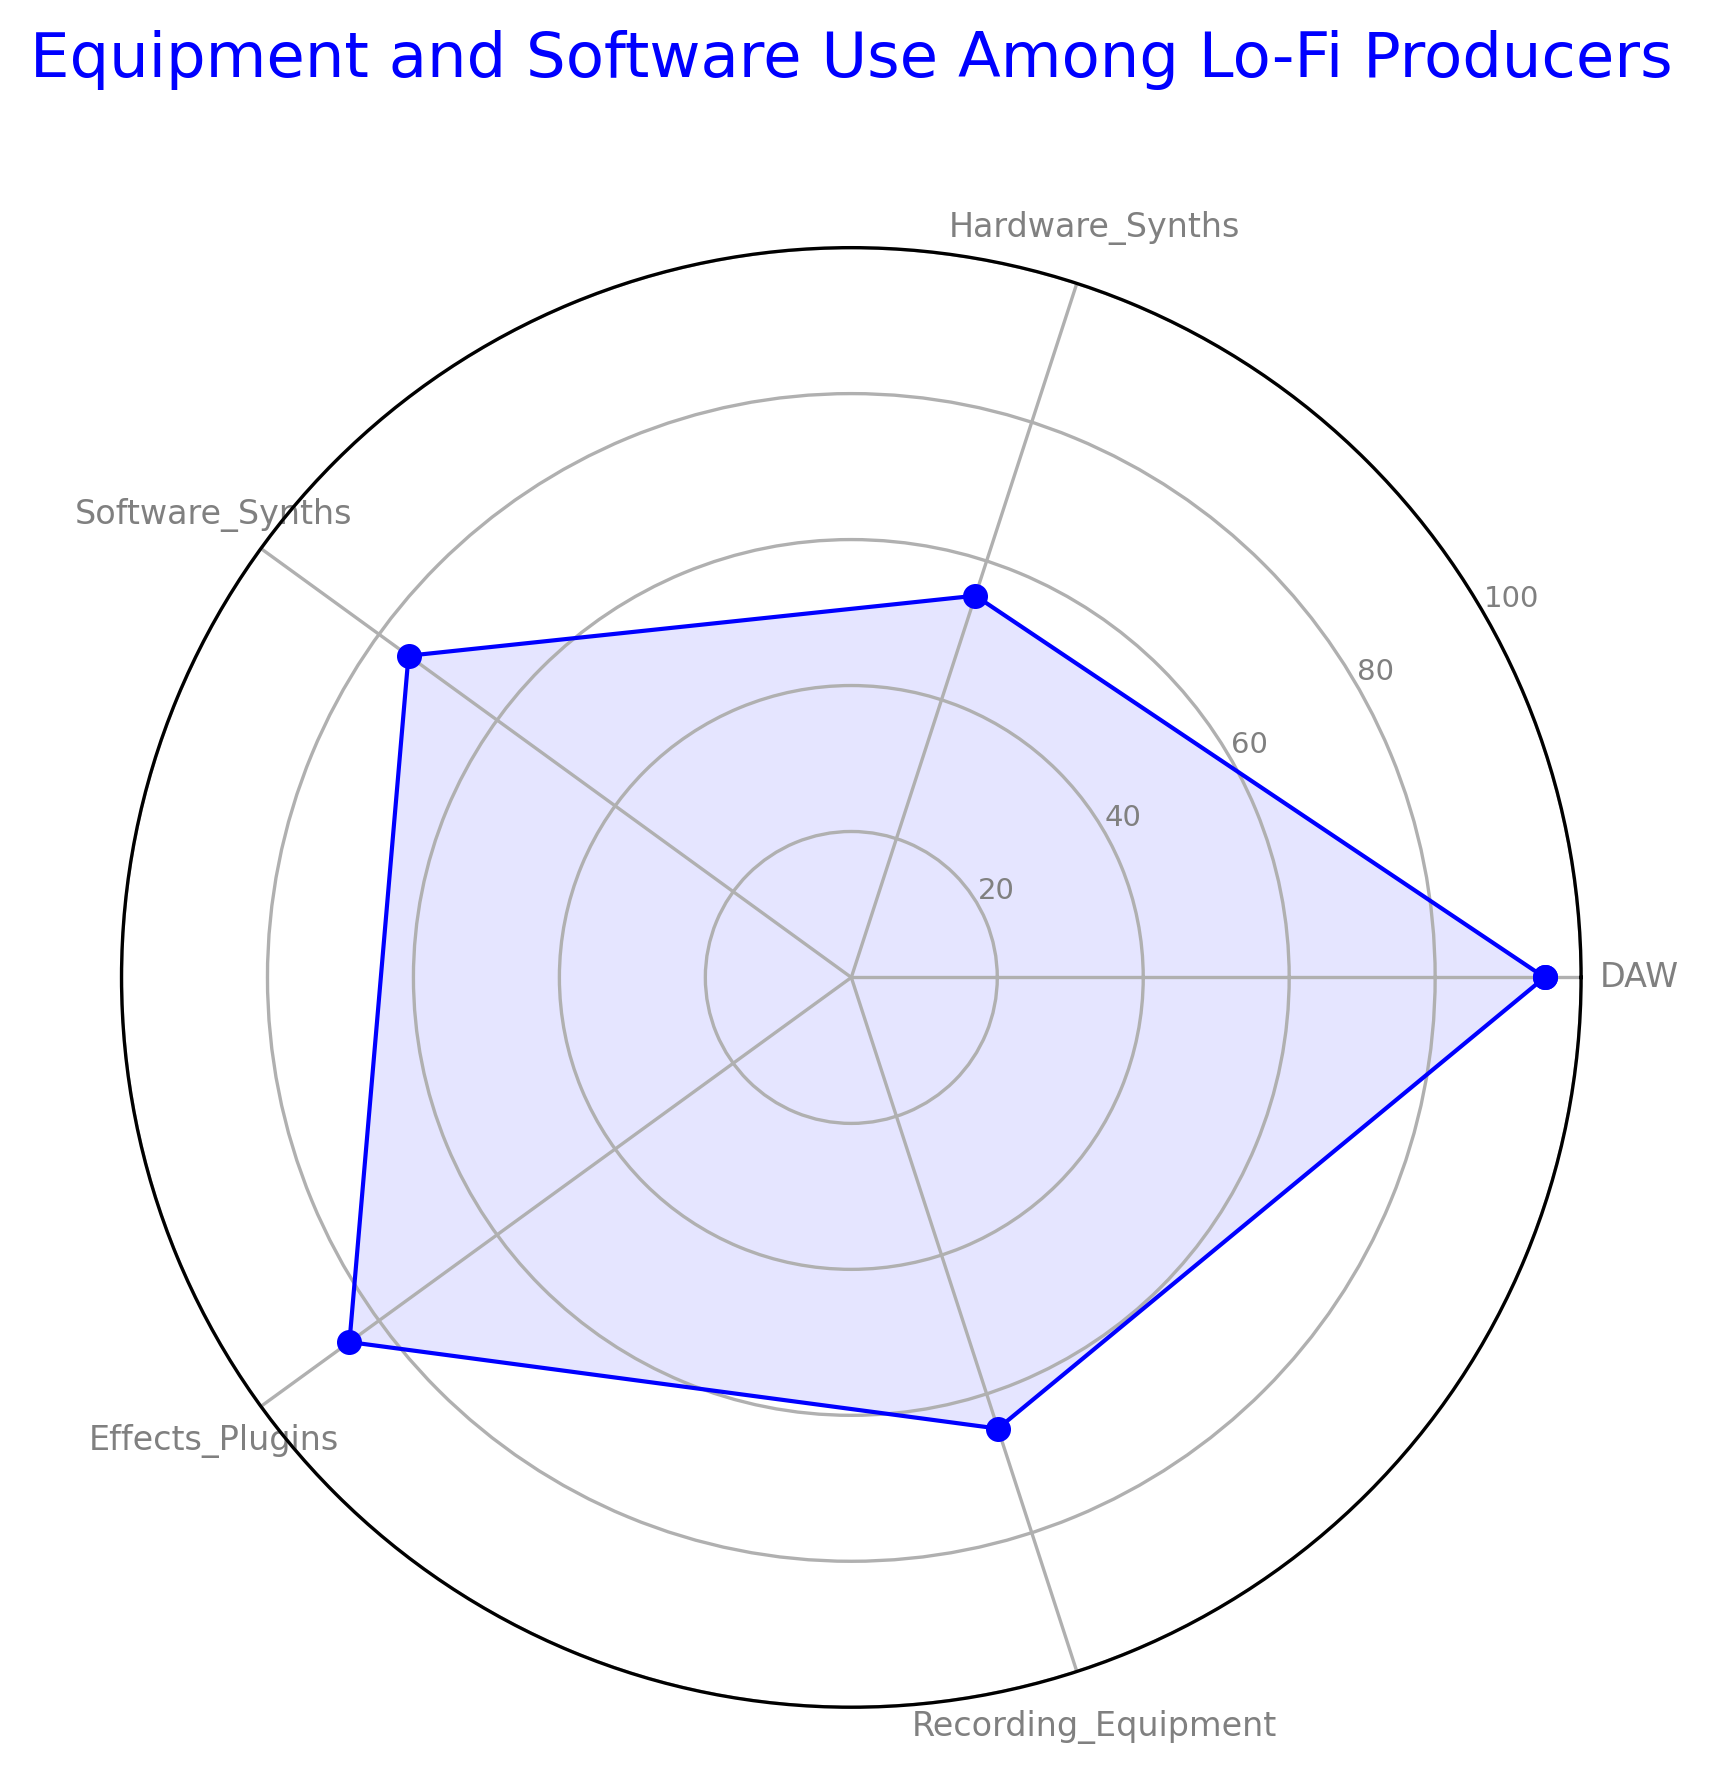Which category has the highest usage percentage? From the chart, identify the longest spoke of the radar plot, which represents the highest value. The longest spoke points to DAW with a usage percentage of 95.
Answer: DAW Which category has the lowest usage percentage? From the chart, look for the shortest spoke of the radar plot. The shortest spoke points to Hardware Synths with a usage percentage of 55.
Answer: Hardware Synths How much more is the usage percentage of DAW compared to Hardware Synths? Note the usage percentages of DAW (95) and Hardware Synths (55). Subtract the latter from the former: 95 - 55 = 40.
Answer: 40 What is the average usage percentage of Software Synths and Effects Plugins? Sum the usage percentages of Software Synths (75) and Effects Plugins (85). Then, divide the sum by 2: (75 + 85) / 2 = 80.
Answer: 80 By how much does the usage percentage of Recording Equipment differ from Software Synths? Note the usage percentages of Recording Equipment (65) and Software Synths (75). Subtract the smaller value from the larger: 75 - 65 = 10.
Answer: 10 Which categories have a usage percentage greater than 70%? From the chart, identify the spokes that extend beyond the 70% mark. The categories are DAW (95), Software Synths (75), and Effects Plugins (85).
Answer: DAW, Software Synths, Effects Plugins If we combine the usage percentages of Hardware Synths and Recording Equipment, what is the total? Sum the usage percentages of Hardware Synths (55) and Recording Equipment (65): 55 + 65 = 120.
Answer: 120 What is the median usage percentage among all categories? Arrange the usage percentages in ascending order: 55, 65, 75, 85, 95. The middle value (third value) in this ordered list is the median. Thus, the median value is 75.
Answer: 75 